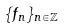<formula> <loc_0><loc_0><loc_500><loc_500>\{ f _ { n } \} _ { n \in \mathbb { Z } }</formula> 